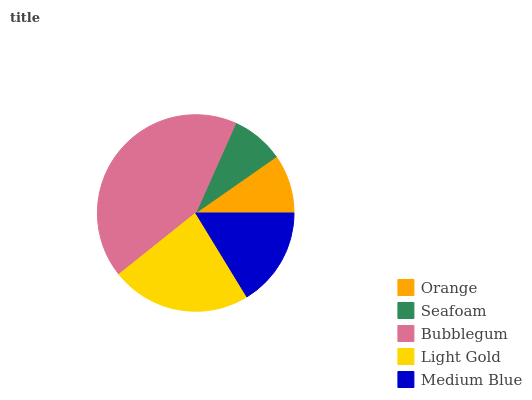Is Seafoam the minimum?
Answer yes or no. Yes. Is Bubblegum the maximum?
Answer yes or no. Yes. Is Bubblegum the minimum?
Answer yes or no. No. Is Seafoam the maximum?
Answer yes or no. No. Is Bubblegum greater than Seafoam?
Answer yes or no. Yes. Is Seafoam less than Bubblegum?
Answer yes or no. Yes. Is Seafoam greater than Bubblegum?
Answer yes or no. No. Is Bubblegum less than Seafoam?
Answer yes or no. No. Is Medium Blue the high median?
Answer yes or no. Yes. Is Medium Blue the low median?
Answer yes or no. Yes. Is Orange the high median?
Answer yes or no. No. Is Orange the low median?
Answer yes or no. No. 